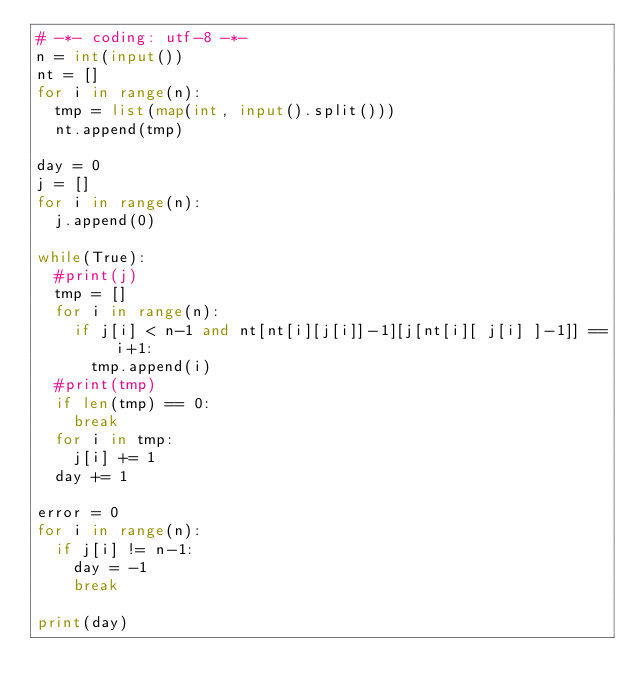<code> <loc_0><loc_0><loc_500><loc_500><_Python_># -*- coding: utf-8 -*-
n = int(input())
nt = []
for i in range(n):
  tmp = list(map(int, input().split()))
  nt.append(tmp)

day = 0
j = []
for i in range(n):
  j.append(0)
  
while(True):
  #print(j)
  tmp = []
  for i in range(n):
    if j[i] < n-1 and nt[nt[i][j[i]]-1][j[nt[i][ j[i] ]-1]] == i+1:
      tmp.append(i)
  #print(tmp)
  if len(tmp) == 0:
    break
  for i in tmp:
    j[i] += 1
  day += 1
  
error = 0
for i in range(n):
  if j[i] != n-1:
    day = -1
    break

print(day)
</code> 